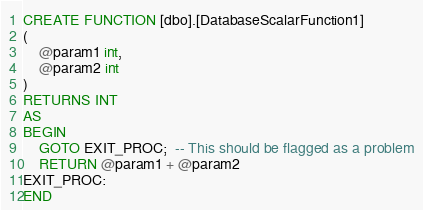Convert code to text. <code><loc_0><loc_0><loc_500><loc_500><_SQL_>CREATE FUNCTION [dbo].[DatabaseScalarFunction1]
(
    @param1 int,
    @param2 int
)
RETURNS INT
AS
BEGIN
    GOTO EXIT_PROC;  -- This should be flagged as a problem
    RETURN @param1 + @param2
EXIT_PROC:    
END
</code> 